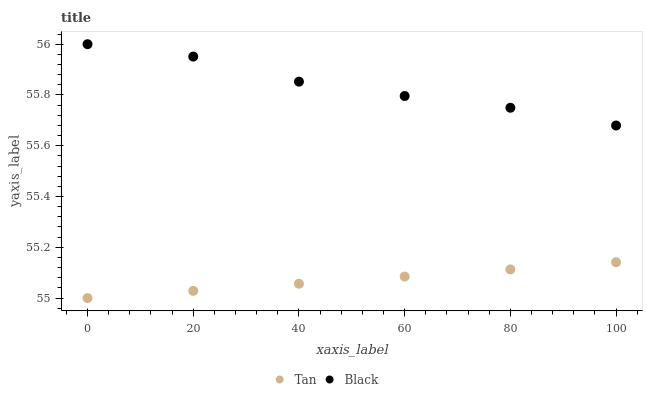Does Tan have the minimum area under the curve?
Answer yes or no. Yes. Does Black have the maximum area under the curve?
Answer yes or no. Yes. Does Black have the minimum area under the curve?
Answer yes or no. No. Is Tan the smoothest?
Answer yes or no. Yes. Is Black the roughest?
Answer yes or no. Yes. Is Black the smoothest?
Answer yes or no. No. Does Tan have the lowest value?
Answer yes or no. Yes. Does Black have the lowest value?
Answer yes or no. No. Does Black have the highest value?
Answer yes or no. Yes. Is Tan less than Black?
Answer yes or no. Yes. Is Black greater than Tan?
Answer yes or no. Yes. Does Tan intersect Black?
Answer yes or no. No. 